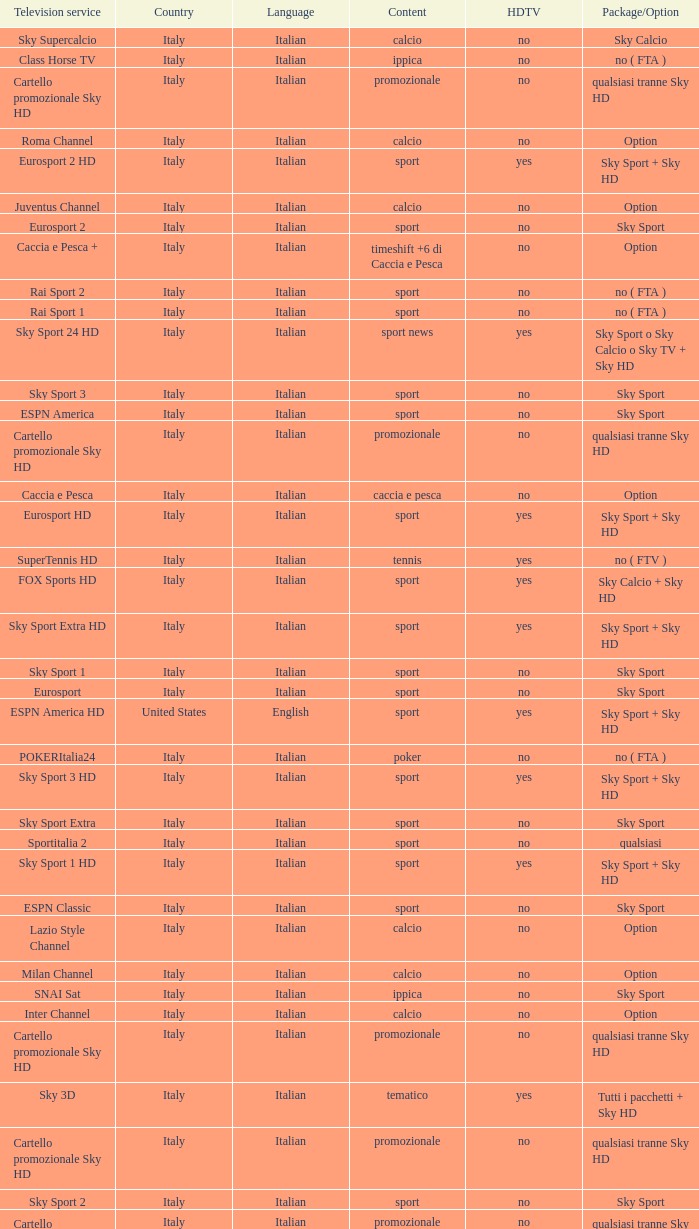What is Package/Option, when Content is Tennis? No ( ftv ). 